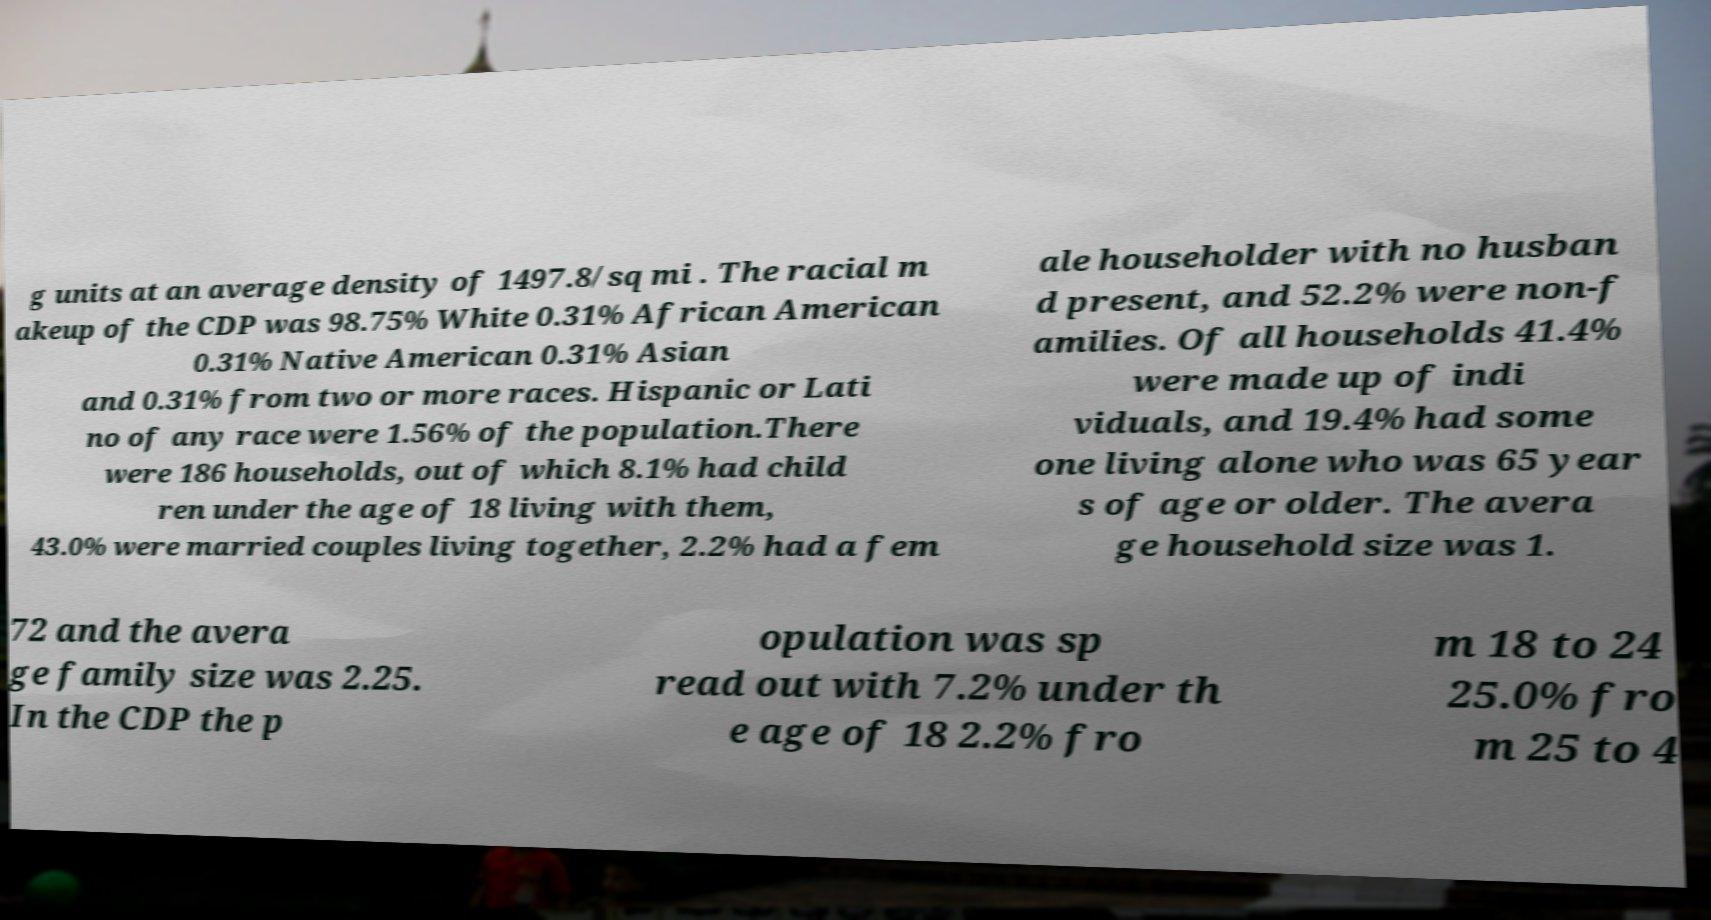For documentation purposes, I need the text within this image transcribed. Could you provide that? g units at an average density of 1497.8/sq mi . The racial m akeup of the CDP was 98.75% White 0.31% African American 0.31% Native American 0.31% Asian and 0.31% from two or more races. Hispanic or Lati no of any race were 1.56% of the population.There were 186 households, out of which 8.1% had child ren under the age of 18 living with them, 43.0% were married couples living together, 2.2% had a fem ale householder with no husban d present, and 52.2% were non-f amilies. Of all households 41.4% were made up of indi viduals, and 19.4% had some one living alone who was 65 year s of age or older. The avera ge household size was 1. 72 and the avera ge family size was 2.25. In the CDP the p opulation was sp read out with 7.2% under th e age of 18 2.2% fro m 18 to 24 25.0% fro m 25 to 4 